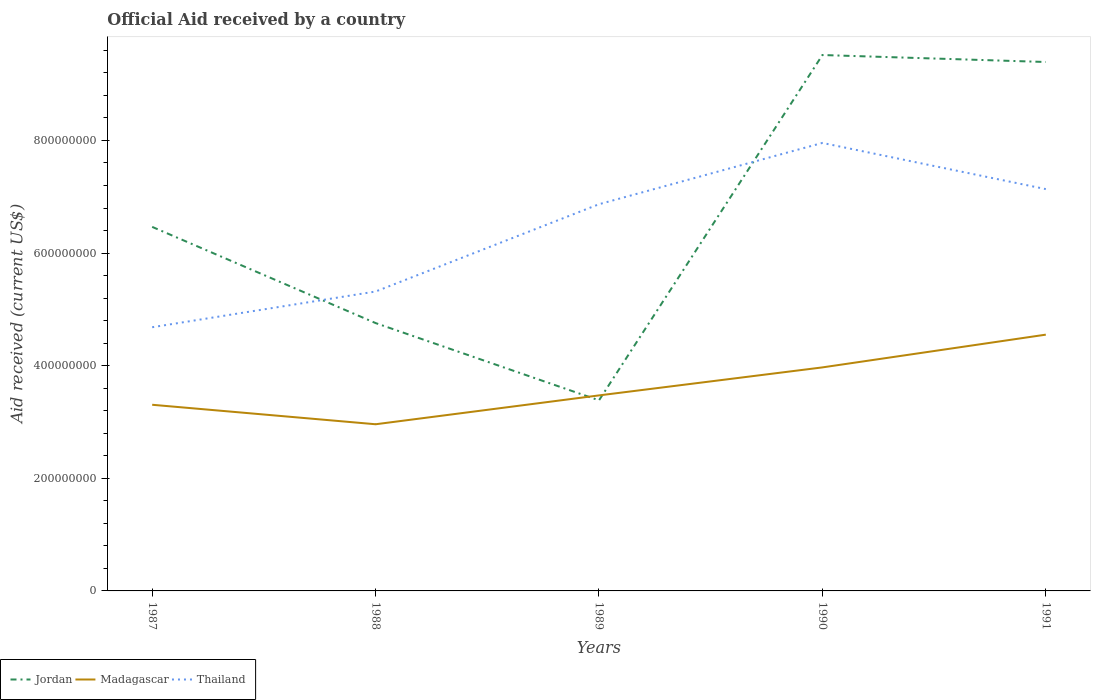How many different coloured lines are there?
Offer a very short reply. 3. Across all years, what is the maximum net official aid received in Jordan?
Give a very brief answer. 3.38e+08. In which year was the net official aid received in Madagascar maximum?
Keep it short and to the point. 1988. What is the total net official aid received in Thailand in the graph?
Your answer should be compact. 8.20e+07. What is the difference between the highest and the second highest net official aid received in Jordan?
Your answer should be very brief. 6.13e+08. What is the difference between the highest and the lowest net official aid received in Thailand?
Your response must be concise. 3. Is the net official aid received in Jordan strictly greater than the net official aid received in Madagascar over the years?
Provide a short and direct response. No. Are the values on the major ticks of Y-axis written in scientific E-notation?
Offer a very short reply. No. Does the graph contain any zero values?
Keep it short and to the point. No. Does the graph contain grids?
Offer a very short reply. No. Where does the legend appear in the graph?
Offer a very short reply. Bottom left. How many legend labels are there?
Make the answer very short. 3. How are the legend labels stacked?
Your answer should be very brief. Horizontal. What is the title of the graph?
Provide a succinct answer. Official Aid received by a country. What is the label or title of the Y-axis?
Provide a succinct answer. Aid received (current US$). What is the Aid received (current US$) in Jordan in 1987?
Keep it short and to the point. 6.46e+08. What is the Aid received (current US$) of Madagascar in 1987?
Offer a terse response. 3.31e+08. What is the Aid received (current US$) in Thailand in 1987?
Ensure brevity in your answer.  4.68e+08. What is the Aid received (current US$) of Jordan in 1988?
Make the answer very short. 4.76e+08. What is the Aid received (current US$) of Madagascar in 1988?
Your response must be concise. 2.96e+08. What is the Aid received (current US$) in Thailand in 1988?
Your response must be concise. 5.32e+08. What is the Aid received (current US$) in Jordan in 1989?
Your answer should be compact. 3.38e+08. What is the Aid received (current US$) of Madagascar in 1989?
Ensure brevity in your answer.  3.47e+08. What is the Aid received (current US$) of Thailand in 1989?
Make the answer very short. 6.87e+08. What is the Aid received (current US$) in Jordan in 1990?
Provide a short and direct response. 9.52e+08. What is the Aid received (current US$) of Madagascar in 1990?
Keep it short and to the point. 3.97e+08. What is the Aid received (current US$) in Thailand in 1990?
Provide a short and direct response. 7.96e+08. What is the Aid received (current US$) in Jordan in 1991?
Provide a succinct answer. 9.39e+08. What is the Aid received (current US$) in Madagascar in 1991?
Your answer should be compact. 4.55e+08. What is the Aid received (current US$) in Thailand in 1991?
Provide a short and direct response. 7.14e+08. Across all years, what is the maximum Aid received (current US$) of Jordan?
Ensure brevity in your answer.  9.52e+08. Across all years, what is the maximum Aid received (current US$) of Madagascar?
Your answer should be very brief. 4.55e+08. Across all years, what is the maximum Aid received (current US$) of Thailand?
Your answer should be very brief. 7.96e+08. Across all years, what is the minimum Aid received (current US$) of Jordan?
Offer a terse response. 3.38e+08. Across all years, what is the minimum Aid received (current US$) of Madagascar?
Your response must be concise. 2.96e+08. Across all years, what is the minimum Aid received (current US$) in Thailand?
Offer a very short reply. 4.68e+08. What is the total Aid received (current US$) in Jordan in the graph?
Your answer should be very brief. 3.35e+09. What is the total Aid received (current US$) of Madagascar in the graph?
Offer a very short reply. 1.83e+09. What is the total Aid received (current US$) in Thailand in the graph?
Give a very brief answer. 3.20e+09. What is the difference between the Aid received (current US$) in Jordan in 1987 and that in 1988?
Give a very brief answer. 1.71e+08. What is the difference between the Aid received (current US$) in Madagascar in 1987 and that in 1988?
Your response must be concise. 3.46e+07. What is the difference between the Aid received (current US$) in Thailand in 1987 and that in 1988?
Ensure brevity in your answer.  -6.34e+07. What is the difference between the Aid received (current US$) of Jordan in 1987 and that in 1989?
Provide a succinct answer. 3.08e+08. What is the difference between the Aid received (current US$) in Madagascar in 1987 and that in 1989?
Your answer should be compact. -1.66e+07. What is the difference between the Aid received (current US$) of Thailand in 1987 and that in 1989?
Provide a succinct answer. -2.18e+08. What is the difference between the Aid received (current US$) of Jordan in 1987 and that in 1990?
Your response must be concise. -3.05e+08. What is the difference between the Aid received (current US$) in Madagascar in 1987 and that in 1990?
Your response must be concise. -6.64e+07. What is the difference between the Aid received (current US$) in Thailand in 1987 and that in 1990?
Give a very brief answer. -3.27e+08. What is the difference between the Aid received (current US$) in Jordan in 1987 and that in 1991?
Offer a terse response. -2.93e+08. What is the difference between the Aid received (current US$) of Madagascar in 1987 and that in 1991?
Your response must be concise. -1.25e+08. What is the difference between the Aid received (current US$) in Thailand in 1987 and that in 1991?
Your response must be concise. -2.45e+08. What is the difference between the Aid received (current US$) of Jordan in 1988 and that in 1989?
Your answer should be compact. 1.37e+08. What is the difference between the Aid received (current US$) in Madagascar in 1988 and that in 1989?
Offer a terse response. -5.12e+07. What is the difference between the Aid received (current US$) of Thailand in 1988 and that in 1989?
Keep it short and to the point. -1.55e+08. What is the difference between the Aid received (current US$) of Jordan in 1988 and that in 1990?
Ensure brevity in your answer.  -4.76e+08. What is the difference between the Aid received (current US$) of Madagascar in 1988 and that in 1990?
Make the answer very short. -1.01e+08. What is the difference between the Aid received (current US$) in Thailand in 1988 and that in 1990?
Provide a succinct answer. -2.64e+08. What is the difference between the Aid received (current US$) in Jordan in 1988 and that in 1991?
Make the answer very short. -4.64e+08. What is the difference between the Aid received (current US$) in Madagascar in 1988 and that in 1991?
Your response must be concise. -1.59e+08. What is the difference between the Aid received (current US$) in Thailand in 1988 and that in 1991?
Ensure brevity in your answer.  -1.82e+08. What is the difference between the Aid received (current US$) in Jordan in 1989 and that in 1990?
Ensure brevity in your answer.  -6.13e+08. What is the difference between the Aid received (current US$) in Madagascar in 1989 and that in 1990?
Offer a terse response. -4.97e+07. What is the difference between the Aid received (current US$) in Thailand in 1989 and that in 1990?
Offer a very short reply. -1.09e+08. What is the difference between the Aid received (current US$) of Jordan in 1989 and that in 1991?
Keep it short and to the point. -6.01e+08. What is the difference between the Aid received (current US$) of Madagascar in 1989 and that in 1991?
Your answer should be compact. -1.08e+08. What is the difference between the Aid received (current US$) of Thailand in 1989 and that in 1991?
Offer a terse response. -2.68e+07. What is the difference between the Aid received (current US$) of Jordan in 1990 and that in 1991?
Offer a very short reply. 1.24e+07. What is the difference between the Aid received (current US$) in Madagascar in 1990 and that in 1991?
Your answer should be compact. -5.82e+07. What is the difference between the Aid received (current US$) of Thailand in 1990 and that in 1991?
Keep it short and to the point. 8.20e+07. What is the difference between the Aid received (current US$) of Jordan in 1987 and the Aid received (current US$) of Madagascar in 1988?
Make the answer very short. 3.51e+08. What is the difference between the Aid received (current US$) of Jordan in 1987 and the Aid received (current US$) of Thailand in 1988?
Your answer should be very brief. 1.15e+08. What is the difference between the Aid received (current US$) in Madagascar in 1987 and the Aid received (current US$) in Thailand in 1988?
Ensure brevity in your answer.  -2.01e+08. What is the difference between the Aid received (current US$) in Jordan in 1987 and the Aid received (current US$) in Madagascar in 1989?
Provide a succinct answer. 2.99e+08. What is the difference between the Aid received (current US$) in Jordan in 1987 and the Aid received (current US$) in Thailand in 1989?
Your answer should be compact. -4.02e+07. What is the difference between the Aid received (current US$) in Madagascar in 1987 and the Aid received (current US$) in Thailand in 1989?
Your answer should be very brief. -3.56e+08. What is the difference between the Aid received (current US$) in Jordan in 1987 and the Aid received (current US$) in Madagascar in 1990?
Offer a very short reply. 2.50e+08. What is the difference between the Aid received (current US$) in Jordan in 1987 and the Aid received (current US$) in Thailand in 1990?
Keep it short and to the point. -1.49e+08. What is the difference between the Aid received (current US$) in Madagascar in 1987 and the Aid received (current US$) in Thailand in 1990?
Offer a terse response. -4.65e+08. What is the difference between the Aid received (current US$) in Jordan in 1987 and the Aid received (current US$) in Madagascar in 1991?
Provide a short and direct response. 1.91e+08. What is the difference between the Aid received (current US$) in Jordan in 1987 and the Aid received (current US$) in Thailand in 1991?
Provide a succinct answer. -6.71e+07. What is the difference between the Aid received (current US$) in Madagascar in 1987 and the Aid received (current US$) in Thailand in 1991?
Offer a very short reply. -3.83e+08. What is the difference between the Aid received (current US$) in Jordan in 1988 and the Aid received (current US$) in Madagascar in 1989?
Keep it short and to the point. 1.28e+08. What is the difference between the Aid received (current US$) in Jordan in 1988 and the Aid received (current US$) in Thailand in 1989?
Provide a short and direct response. -2.11e+08. What is the difference between the Aid received (current US$) of Madagascar in 1988 and the Aid received (current US$) of Thailand in 1989?
Your answer should be compact. -3.91e+08. What is the difference between the Aid received (current US$) in Jordan in 1988 and the Aid received (current US$) in Madagascar in 1990?
Provide a short and direct response. 7.87e+07. What is the difference between the Aid received (current US$) of Jordan in 1988 and the Aid received (current US$) of Thailand in 1990?
Your response must be concise. -3.20e+08. What is the difference between the Aid received (current US$) in Madagascar in 1988 and the Aid received (current US$) in Thailand in 1990?
Keep it short and to the point. -5.00e+08. What is the difference between the Aid received (current US$) in Jordan in 1988 and the Aid received (current US$) in Madagascar in 1991?
Make the answer very short. 2.06e+07. What is the difference between the Aid received (current US$) in Jordan in 1988 and the Aid received (current US$) in Thailand in 1991?
Your answer should be compact. -2.38e+08. What is the difference between the Aid received (current US$) in Madagascar in 1988 and the Aid received (current US$) in Thailand in 1991?
Keep it short and to the point. -4.18e+08. What is the difference between the Aid received (current US$) of Jordan in 1989 and the Aid received (current US$) of Madagascar in 1990?
Your answer should be very brief. -5.85e+07. What is the difference between the Aid received (current US$) in Jordan in 1989 and the Aid received (current US$) in Thailand in 1990?
Your response must be concise. -4.57e+08. What is the difference between the Aid received (current US$) of Madagascar in 1989 and the Aid received (current US$) of Thailand in 1990?
Offer a terse response. -4.48e+08. What is the difference between the Aid received (current US$) of Jordan in 1989 and the Aid received (current US$) of Madagascar in 1991?
Provide a succinct answer. -1.17e+08. What is the difference between the Aid received (current US$) of Jordan in 1989 and the Aid received (current US$) of Thailand in 1991?
Give a very brief answer. -3.75e+08. What is the difference between the Aid received (current US$) in Madagascar in 1989 and the Aid received (current US$) in Thailand in 1991?
Make the answer very short. -3.66e+08. What is the difference between the Aid received (current US$) in Jordan in 1990 and the Aid received (current US$) in Madagascar in 1991?
Give a very brief answer. 4.97e+08. What is the difference between the Aid received (current US$) of Jordan in 1990 and the Aid received (current US$) of Thailand in 1991?
Provide a short and direct response. 2.38e+08. What is the difference between the Aid received (current US$) in Madagascar in 1990 and the Aid received (current US$) in Thailand in 1991?
Keep it short and to the point. -3.17e+08. What is the average Aid received (current US$) in Jordan per year?
Give a very brief answer. 6.70e+08. What is the average Aid received (current US$) of Madagascar per year?
Your answer should be very brief. 3.65e+08. What is the average Aid received (current US$) in Thailand per year?
Offer a very short reply. 6.39e+08. In the year 1987, what is the difference between the Aid received (current US$) of Jordan and Aid received (current US$) of Madagascar?
Your answer should be very brief. 3.16e+08. In the year 1987, what is the difference between the Aid received (current US$) of Jordan and Aid received (current US$) of Thailand?
Keep it short and to the point. 1.78e+08. In the year 1987, what is the difference between the Aid received (current US$) in Madagascar and Aid received (current US$) in Thailand?
Provide a succinct answer. -1.38e+08. In the year 1988, what is the difference between the Aid received (current US$) of Jordan and Aid received (current US$) of Madagascar?
Your answer should be very brief. 1.80e+08. In the year 1988, what is the difference between the Aid received (current US$) in Jordan and Aid received (current US$) in Thailand?
Keep it short and to the point. -5.60e+07. In the year 1988, what is the difference between the Aid received (current US$) of Madagascar and Aid received (current US$) of Thailand?
Offer a very short reply. -2.36e+08. In the year 1989, what is the difference between the Aid received (current US$) in Jordan and Aid received (current US$) in Madagascar?
Offer a very short reply. -8.76e+06. In the year 1989, what is the difference between the Aid received (current US$) in Jordan and Aid received (current US$) in Thailand?
Keep it short and to the point. -3.48e+08. In the year 1989, what is the difference between the Aid received (current US$) in Madagascar and Aid received (current US$) in Thailand?
Offer a terse response. -3.40e+08. In the year 1990, what is the difference between the Aid received (current US$) of Jordan and Aid received (current US$) of Madagascar?
Your response must be concise. 5.55e+08. In the year 1990, what is the difference between the Aid received (current US$) in Jordan and Aid received (current US$) in Thailand?
Ensure brevity in your answer.  1.56e+08. In the year 1990, what is the difference between the Aid received (current US$) of Madagascar and Aid received (current US$) of Thailand?
Ensure brevity in your answer.  -3.99e+08. In the year 1991, what is the difference between the Aid received (current US$) in Jordan and Aid received (current US$) in Madagascar?
Ensure brevity in your answer.  4.84e+08. In the year 1991, what is the difference between the Aid received (current US$) of Jordan and Aid received (current US$) of Thailand?
Offer a very short reply. 2.26e+08. In the year 1991, what is the difference between the Aid received (current US$) of Madagascar and Aid received (current US$) of Thailand?
Your answer should be very brief. -2.58e+08. What is the ratio of the Aid received (current US$) in Jordan in 1987 to that in 1988?
Give a very brief answer. 1.36. What is the ratio of the Aid received (current US$) of Madagascar in 1987 to that in 1988?
Your response must be concise. 1.12. What is the ratio of the Aid received (current US$) in Thailand in 1987 to that in 1988?
Offer a terse response. 0.88. What is the ratio of the Aid received (current US$) of Jordan in 1987 to that in 1989?
Your answer should be very brief. 1.91. What is the ratio of the Aid received (current US$) of Madagascar in 1987 to that in 1989?
Provide a short and direct response. 0.95. What is the ratio of the Aid received (current US$) in Thailand in 1987 to that in 1989?
Offer a very short reply. 0.68. What is the ratio of the Aid received (current US$) of Jordan in 1987 to that in 1990?
Your response must be concise. 0.68. What is the ratio of the Aid received (current US$) of Madagascar in 1987 to that in 1990?
Provide a short and direct response. 0.83. What is the ratio of the Aid received (current US$) in Thailand in 1987 to that in 1990?
Offer a very short reply. 0.59. What is the ratio of the Aid received (current US$) in Jordan in 1987 to that in 1991?
Your response must be concise. 0.69. What is the ratio of the Aid received (current US$) in Madagascar in 1987 to that in 1991?
Keep it short and to the point. 0.73. What is the ratio of the Aid received (current US$) of Thailand in 1987 to that in 1991?
Ensure brevity in your answer.  0.66. What is the ratio of the Aid received (current US$) of Jordan in 1988 to that in 1989?
Your answer should be compact. 1.41. What is the ratio of the Aid received (current US$) in Madagascar in 1988 to that in 1989?
Your answer should be compact. 0.85. What is the ratio of the Aid received (current US$) of Thailand in 1988 to that in 1989?
Give a very brief answer. 0.77. What is the ratio of the Aid received (current US$) of Jordan in 1988 to that in 1990?
Ensure brevity in your answer.  0.5. What is the ratio of the Aid received (current US$) in Madagascar in 1988 to that in 1990?
Keep it short and to the point. 0.75. What is the ratio of the Aid received (current US$) in Thailand in 1988 to that in 1990?
Make the answer very short. 0.67. What is the ratio of the Aid received (current US$) of Jordan in 1988 to that in 1991?
Your response must be concise. 0.51. What is the ratio of the Aid received (current US$) in Madagascar in 1988 to that in 1991?
Your response must be concise. 0.65. What is the ratio of the Aid received (current US$) in Thailand in 1988 to that in 1991?
Keep it short and to the point. 0.75. What is the ratio of the Aid received (current US$) of Jordan in 1989 to that in 1990?
Provide a succinct answer. 0.36. What is the ratio of the Aid received (current US$) of Madagascar in 1989 to that in 1990?
Make the answer very short. 0.87. What is the ratio of the Aid received (current US$) in Thailand in 1989 to that in 1990?
Ensure brevity in your answer.  0.86. What is the ratio of the Aid received (current US$) of Jordan in 1989 to that in 1991?
Provide a short and direct response. 0.36. What is the ratio of the Aid received (current US$) of Madagascar in 1989 to that in 1991?
Your answer should be very brief. 0.76. What is the ratio of the Aid received (current US$) in Thailand in 1989 to that in 1991?
Your answer should be compact. 0.96. What is the ratio of the Aid received (current US$) of Jordan in 1990 to that in 1991?
Your answer should be compact. 1.01. What is the ratio of the Aid received (current US$) in Madagascar in 1990 to that in 1991?
Provide a succinct answer. 0.87. What is the ratio of the Aid received (current US$) in Thailand in 1990 to that in 1991?
Make the answer very short. 1.11. What is the difference between the highest and the second highest Aid received (current US$) of Jordan?
Ensure brevity in your answer.  1.24e+07. What is the difference between the highest and the second highest Aid received (current US$) of Madagascar?
Provide a succinct answer. 5.82e+07. What is the difference between the highest and the second highest Aid received (current US$) of Thailand?
Give a very brief answer. 8.20e+07. What is the difference between the highest and the lowest Aid received (current US$) of Jordan?
Provide a succinct answer. 6.13e+08. What is the difference between the highest and the lowest Aid received (current US$) in Madagascar?
Keep it short and to the point. 1.59e+08. What is the difference between the highest and the lowest Aid received (current US$) of Thailand?
Offer a very short reply. 3.27e+08. 